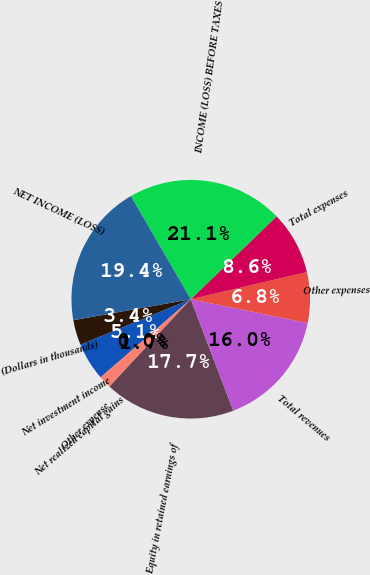<chart> <loc_0><loc_0><loc_500><loc_500><pie_chart><fcel>(Dollars in thousands)<fcel>Net investment income<fcel>Net realized capital gains<fcel>Other expense<fcel>Equity in retained earnings of<fcel>Total revenues<fcel>Other expenses<fcel>Total expenses<fcel>INCOME (LOSS) BEFORE TAXES<fcel>NET INCOME (LOSS)<nl><fcel>3.42%<fcel>5.13%<fcel>0.0%<fcel>1.71%<fcel>17.73%<fcel>16.01%<fcel>6.85%<fcel>8.56%<fcel>21.15%<fcel>19.44%<nl></chart> 